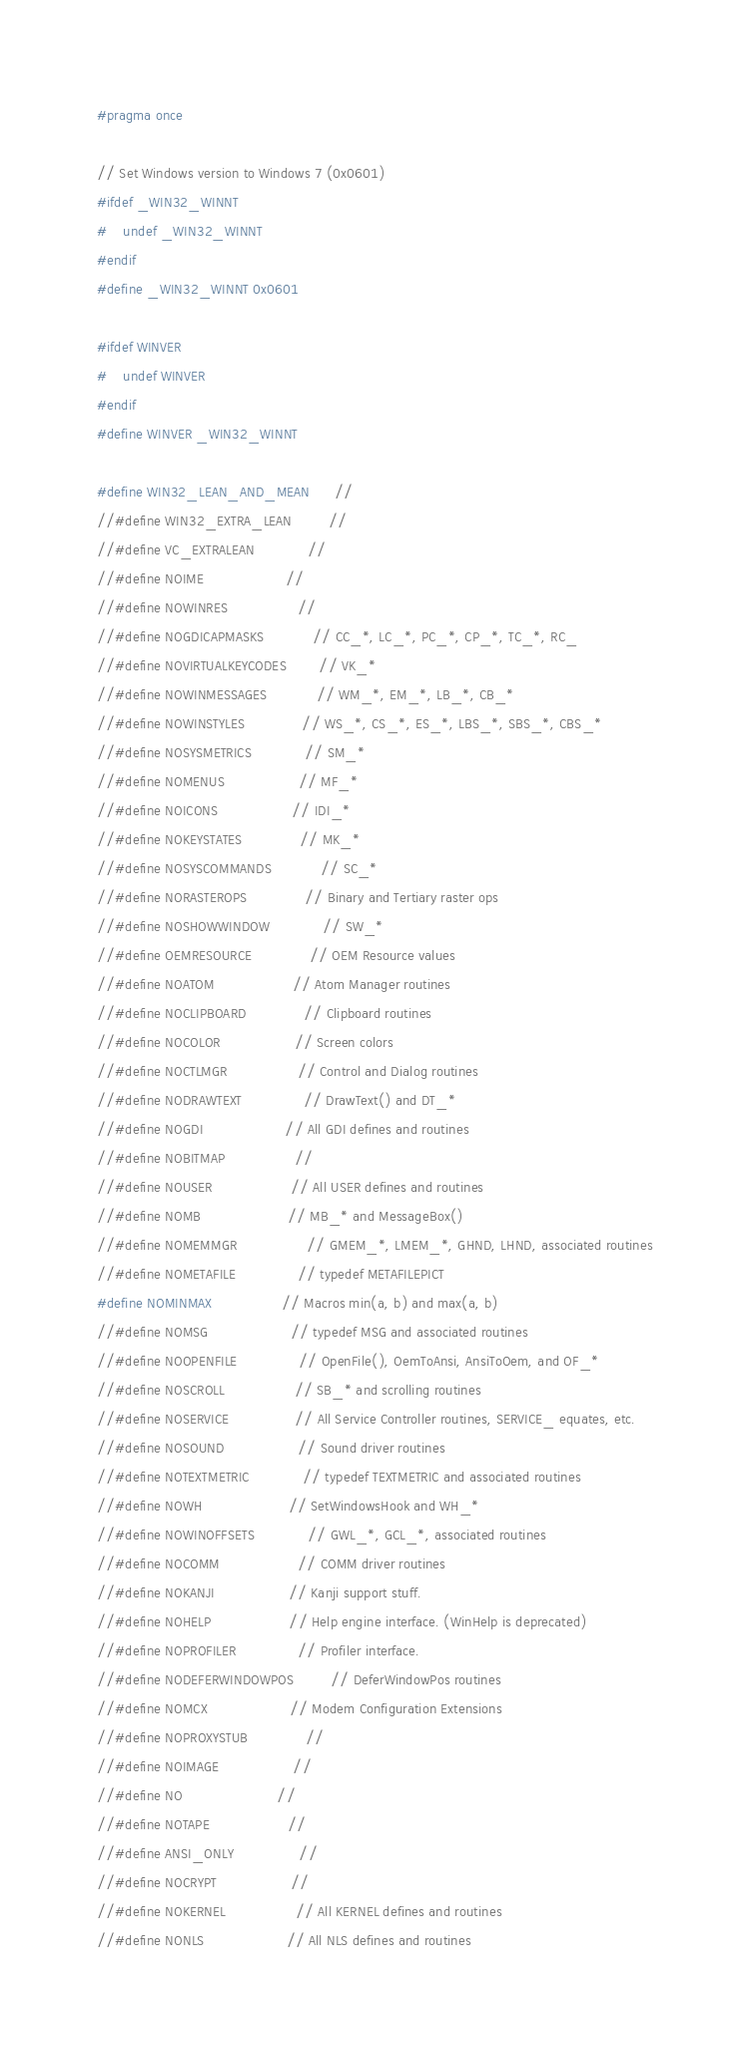Convert code to text. <code><loc_0><loc_0><loc_500><loc_500><_C_>#pragma once

// Set Windows version to Windows 7 (0x0601)
#ifdef _WIN32_WINNT
#	undef _WIN32_WINNT
#endif
#define _WIN32_WINNT 0x0601

#ifdef WINVER
#	undef WINVER
#endif
#define WINVER _WIN32_WINNT

#define WIN32_LEAN_AND_MEAN      // 
//#define WIN32_EXTRA_LEAN         // 
//#define VC_EXTRALEAN             // 
//#define NOIME                    // 
//#define NOWINRES                 // 
//#define NOGDICAPMASKS            // CC_*, LC_*, PC_*, CP_*, TC_*, RC_
//#define NOVIRTUALKEYCODES        // VK_*
//#define NOWINMESSAGES            // WM_*, EM_*, LB_*, CB_*
//#define NOWINSTYLES              // WS_*, CS_*, ES_*, LBS_*, SBS_*, CBS_*
//#define NOSYSMETRICS             // SM_*
//#define NOMENUS                  // MF_*
//#define NOICONS                  // IDI_*
//#define NOKEYSTATES              // MK_*
//#define NOSYSCOMMANDS            // SC_*
//#define NORASTEROPS              // Binary and Tertiary raster ops
//#define NOSHOWWINDOW             // SW_*
//#define OEMRESOURCE              // OEM Resource values
//#define NOATOM                   // Atom Manager routines
//#define NOCLIPBOARD              // Clipboard routines
//#define NOCOLOR                  // Screen colors
//#define NOCTLMGR                 // Control and Dialog routines
//#define NODRAWTEXT               // DrawText() and DT_*
//#define NOGDI                    // All GDI defines and routines
//#define NOBITMAP                 // 
//#define NOUSER                   // All USER defines and routines
//#define NOMB                     // MB_* and MessageBox()
//#define NOMEMMGR                 // GMEM_*, LMEM_*, GHND, LHND, associated routines
//#define NOMETAFILE               // typedef METAFILEPICT
#define NOMINMAX                 // Macros min(a, b) and max(a, b)
//#define NOMSG                    // typedef MSG and associated routines
//#define NOOPENFILE               // OpenFile(), OemToAnsi, AnsiToOem, and OF_*
//#define NOSCROLL                 // SB_* and scrolling routines
//#define NOSERVICE                // All Service Controller routines, SERVICE_ equates, etc.
//#define NOSOUND                  // Sound driver routines
//#define NOTEXTMETRIC             // typedef TEXTMETRIC and associated routines
//#define NOWH                     // SetWindowsHook and WH_*
//#define NOWINOFFSETS             // GWL_*, GCL_*, associated routines
//#define NOCOMM                   // COMM driver routines
//#define NOKANJI                  // Kanji support stuff.
//#define NOHELP                   // Help engine interface. (WinHelp is deprecated)
//#define NOPROFILER               // Profiler interface.
//#define NODEFERWINDOWPOS         // DeferWindowPos routines
//#define NOMCX                    // Modem Configuration Extensions
//#define NOPROXYSTUB              // 
//#define NOIMAGE                  // 
//#define NO                       // 
//#define NOTAPE                   // 
//#define ANSI_ONLY                // 
//#define NOCRYPT                  // 
//#define NOKERNEL                 // All KERNEL defines and routines
//#define NONLS                    // All NLS defines and routines</code> 